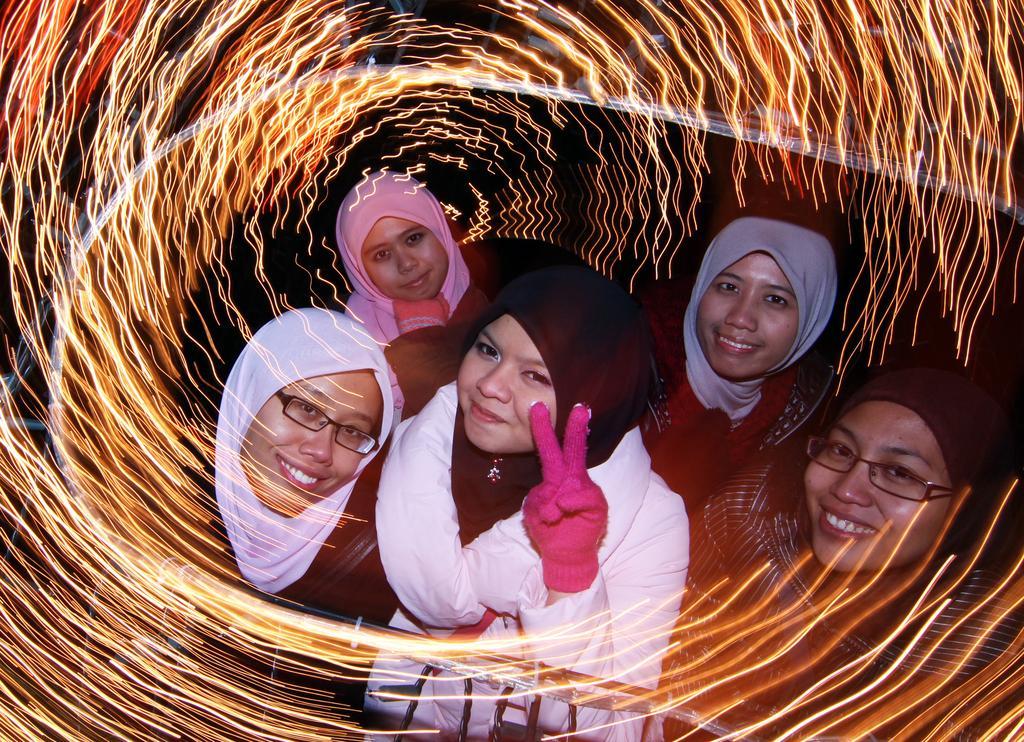Could you give a brief overview of what you see in this image? In this image we can see five ladies wearing scarf on the head. Two are wearing specs. One is wearing glove. And there is a photo effect on the image. 